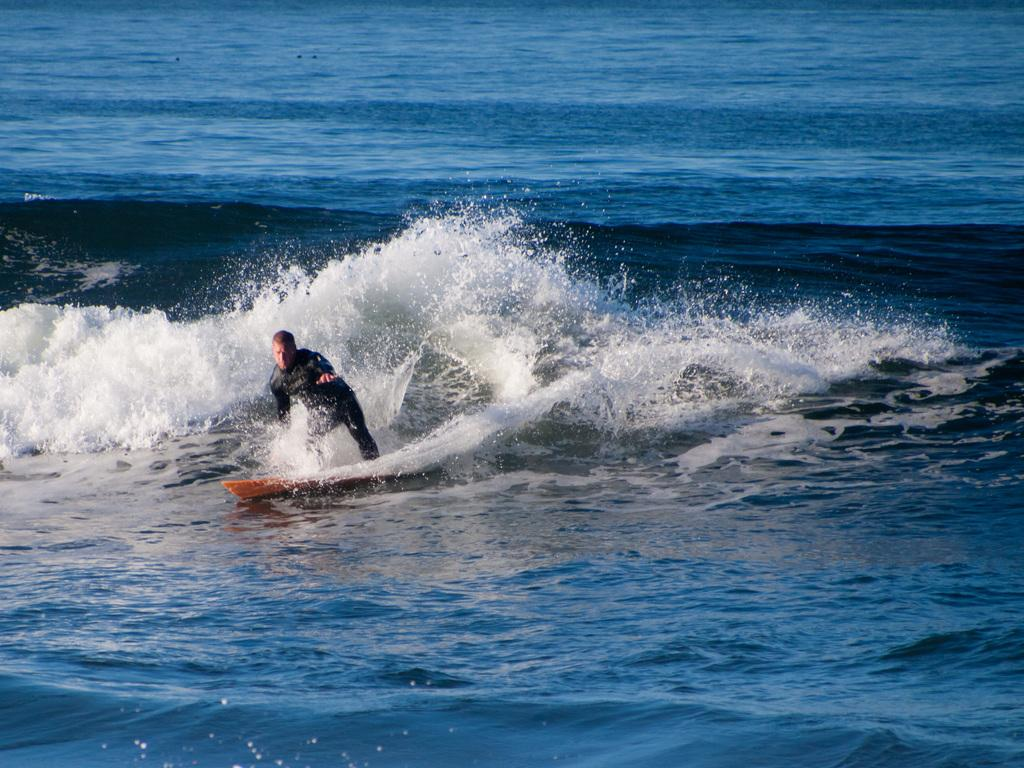Who is the main subject in the image? There is a man in the image. What is the man doing in the image? The man is surfing on a surfing board. What can be seen in the background of the image? There is an ocean in the background of the image. What type of soup is the man eating while surfing in the image? There is no soup present in the image; the man is surfing on a surfing board in an ocean. 